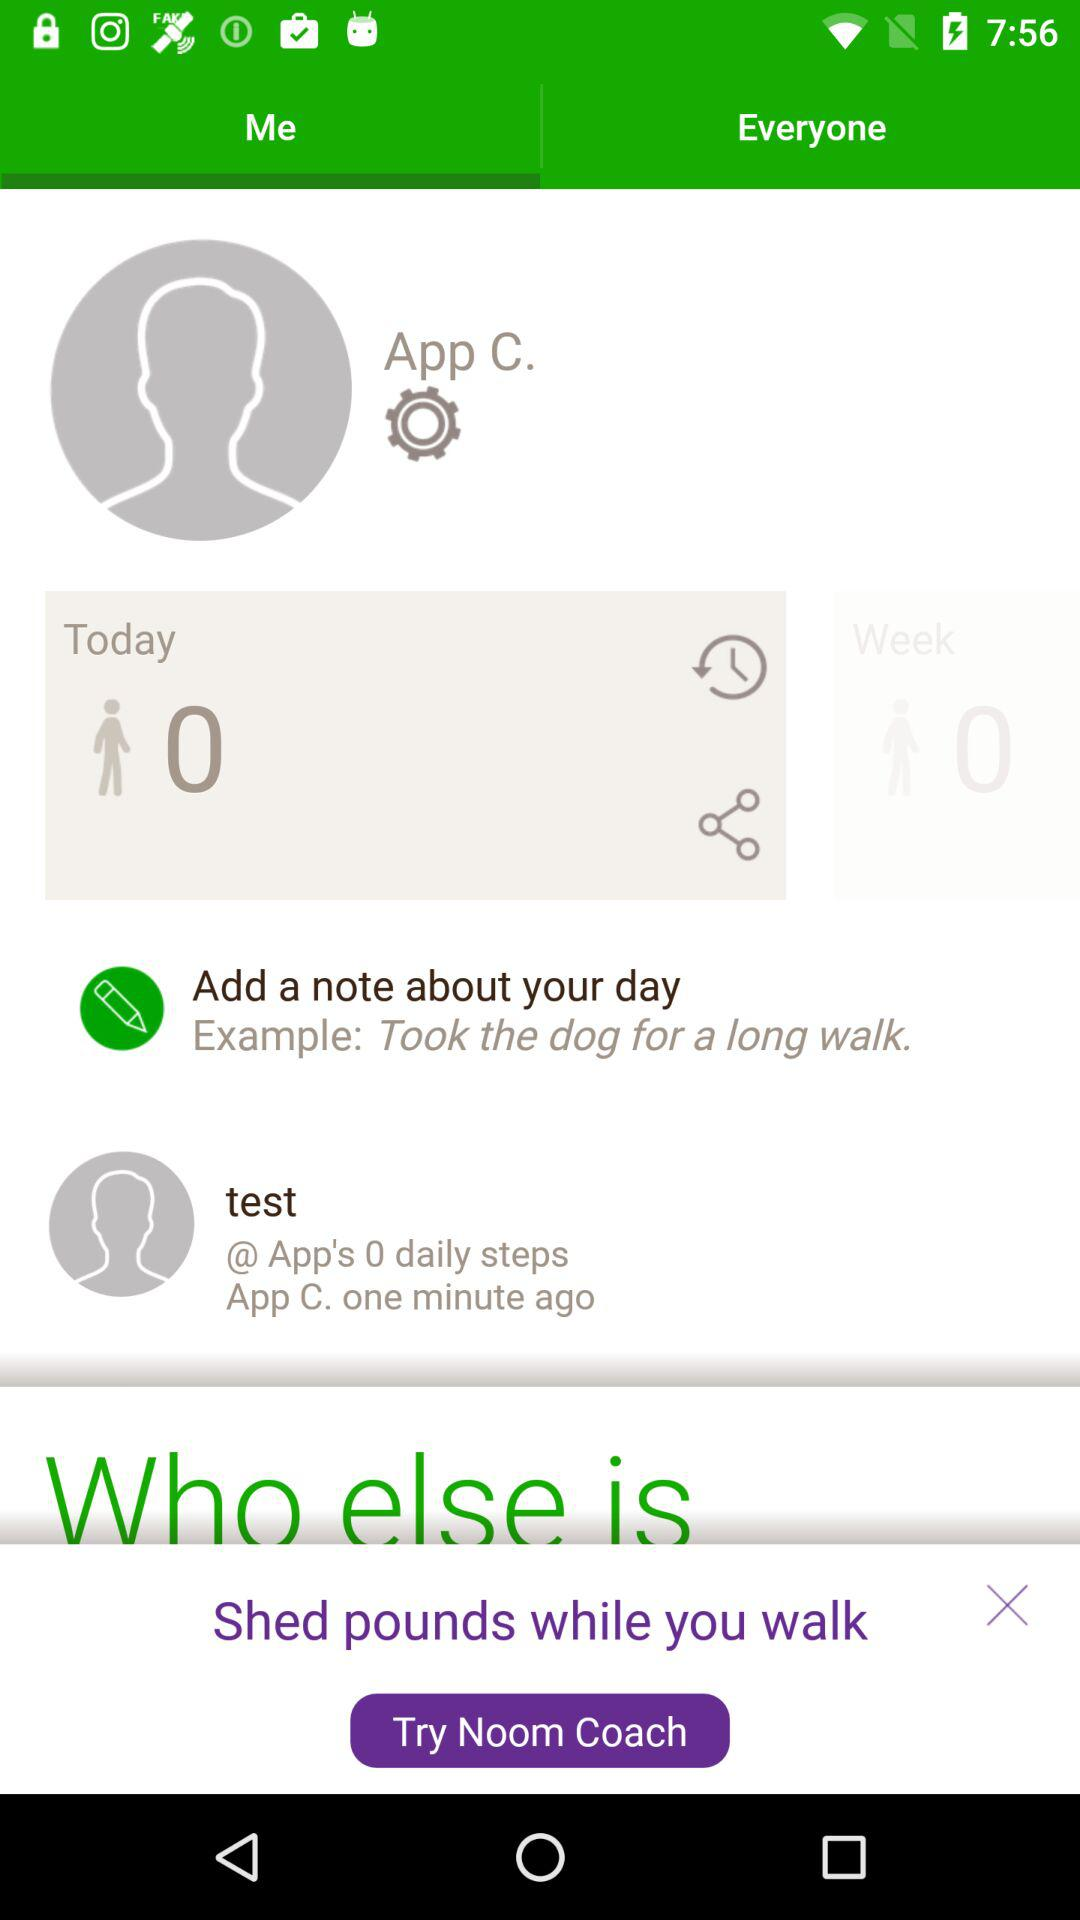How many daily steps are completed? There are 0 completed daily steps. 